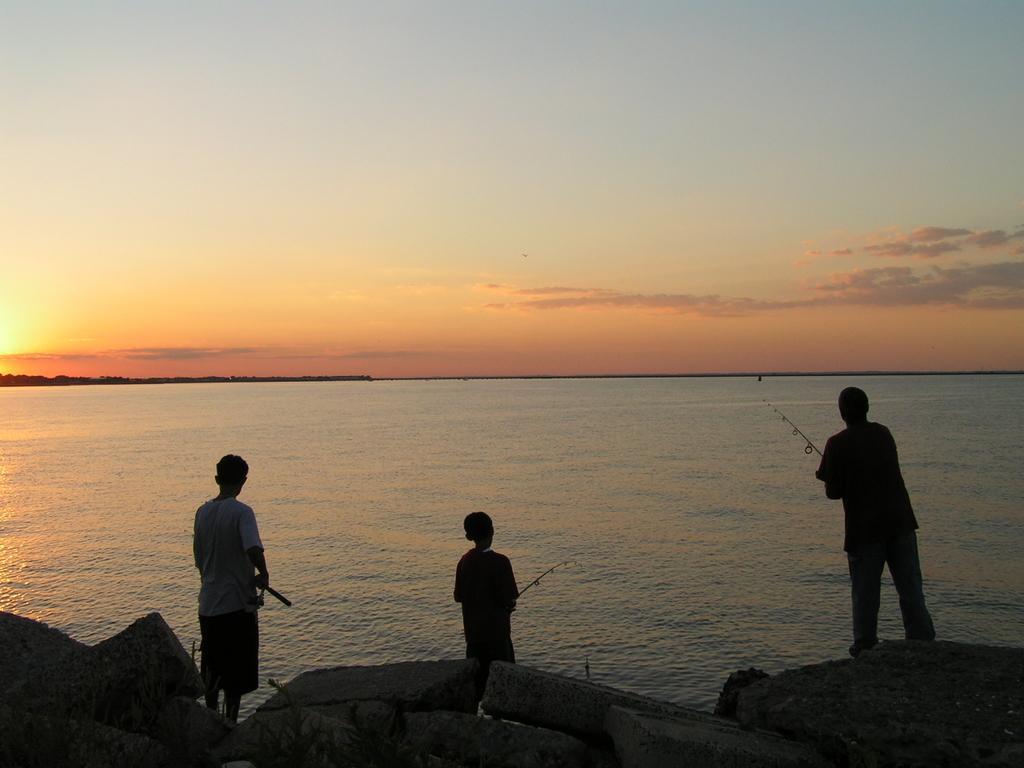Can you describe this image briefly? In this image I can see three boys are fishing in this water, at the top it is the sky. 